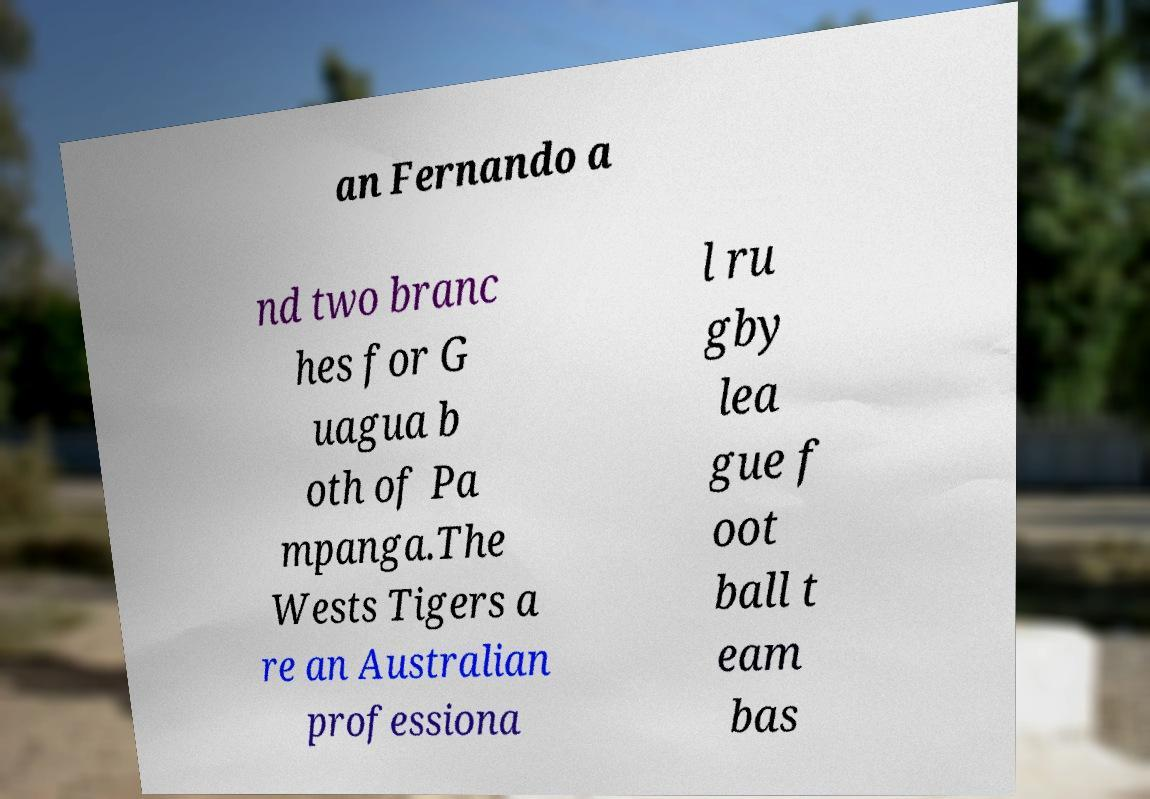Please identify and transcribe the text found in this image. an Fernando a nd two branc hes for G uagua b oth of Pa mpanga.The Wests Tigers a re an Australian professiona l ru gby lea gue f oot ball t eam bas 